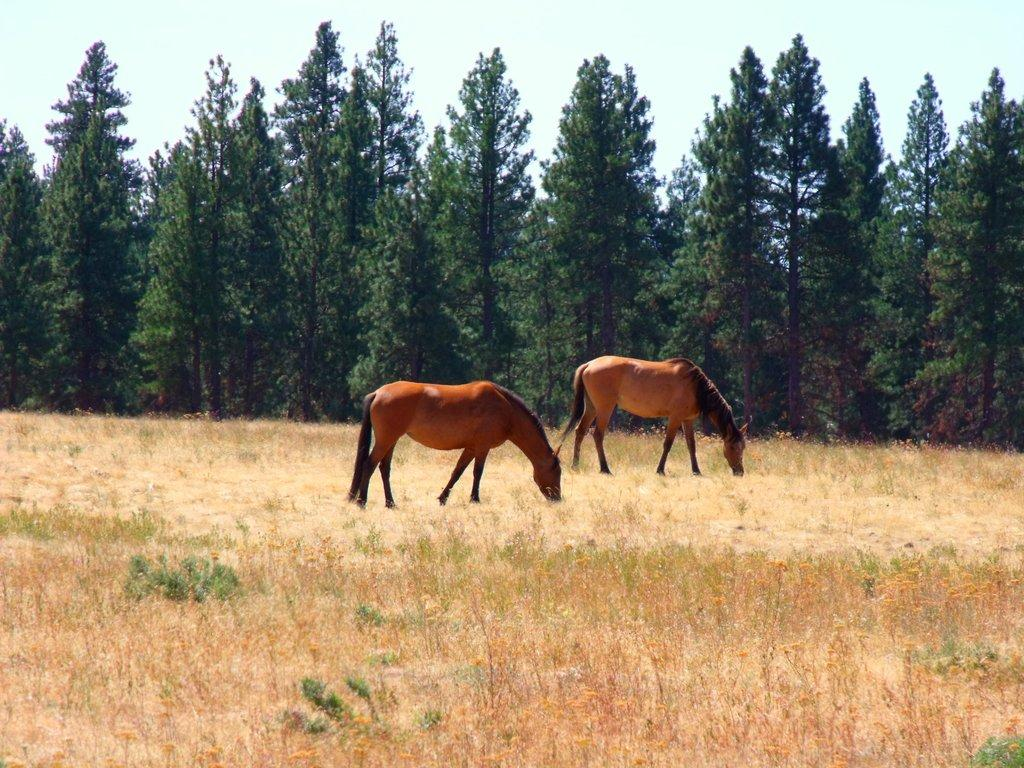How many horses are in the image? There are two horses in the image. What are the horses doing in the image? The horses are eating grass in the image. What type of vegetation is present on the ground? There is grass on the ground in the image. What can be seen in the background of the image? There are trees in the background of the image. What is visible at the top of the image? The sky is visible at the top of the image. What other type of vegetation is present in the image? There are bushes in the image. What books are the horses reading in the image? There are no books present in the image; the horses are eating grass. What type of fish can be seen swimming in the image? There are no fish present in the image; it features two horses eating grass. 